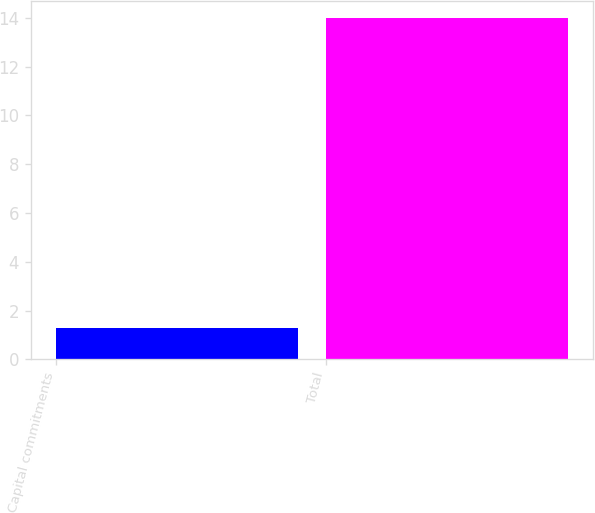Convert chart to OTSL. <chart><loc_0><loc_0><loc_500><loc_500><bar_chart><fcel>Capital commitments<fcel>Total<nl><fcel>1.3<fcel>14<nl></chart> 